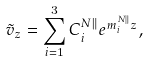Convert formula to latex. <formula><loc_0><loc_0><loc_500><loc_500>\tilde { v } _ { z } = \sum _ { i = 1 } ^ { 3 } C ^ { N \| } _ { i } e ^ { m ^ { N \| } _ { i } z } ,</formula> 